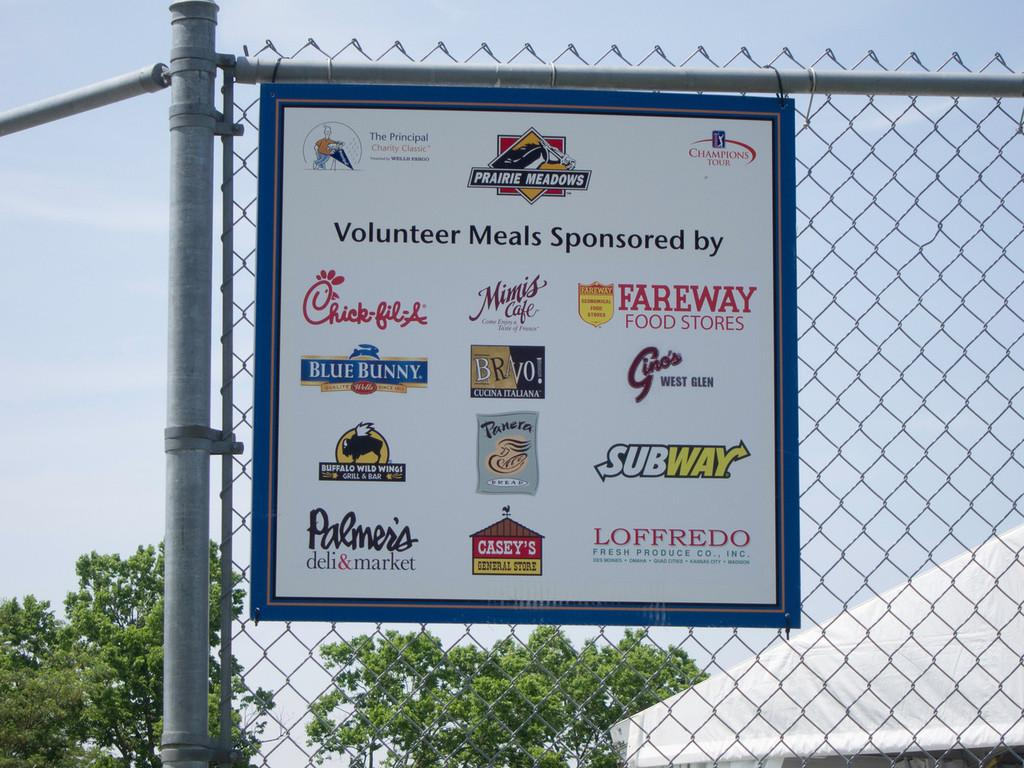<image>
Write a terse but informative summary of the picture. a sign with tons of ads for restraunts like Fareway and Blue Bunny 